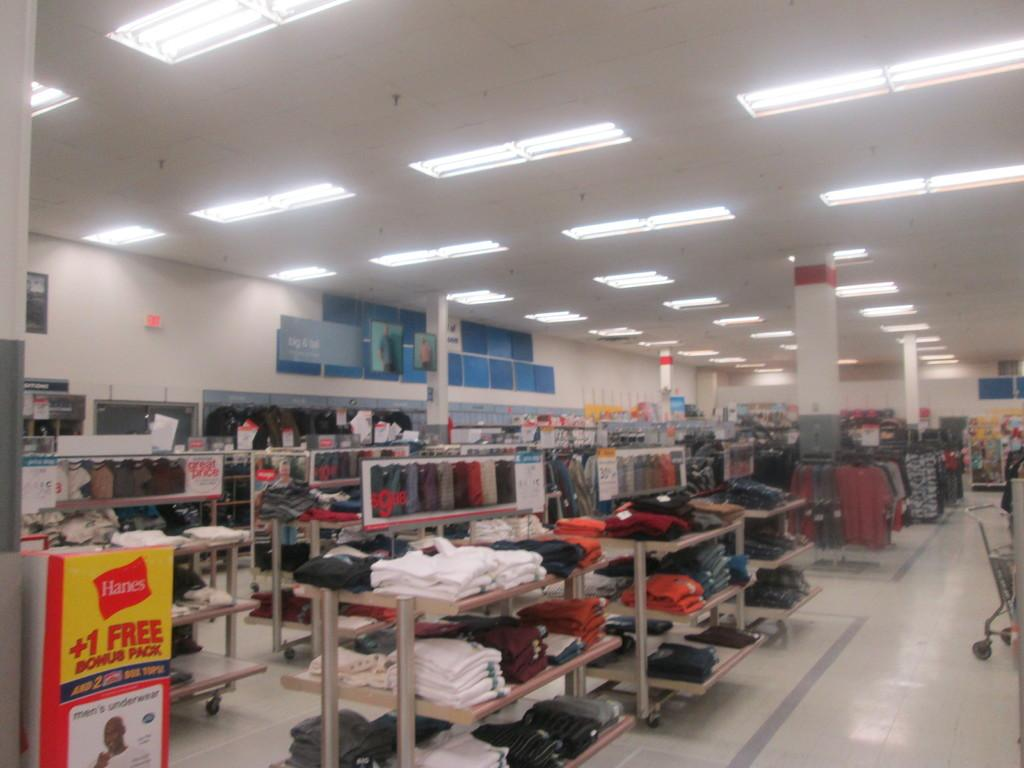Provide a one-sentence caption for the provided image. Clothing section of a store with a sign that says "+1 Free Bonus Pack". 